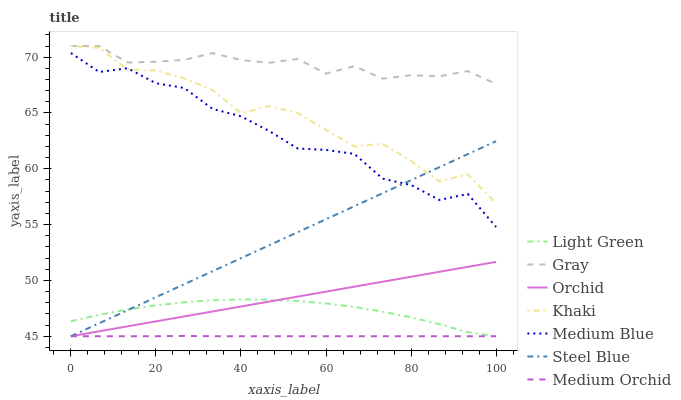Does Khaki have the minimum area under the curve?
Answer yes or no. No. Does Khaki have the maximum area under the curve?
Answer yes or no. No. Is Medium Orchid the smoothest?
Answer yes or no. No. Is Medium Orchid the roughest?
Answer yes or no. No. Does Khaki have the lowest value?
Answer yes or no. No. Does Medium Orchid have the highest value?
Answer yes or no. No. Is Light Green less than Khaki?
Answer yes or no. Yes. Is Gray greater than Light Green?
Answer yes or no. Yes. Does Light Green intersect Khaki?
Answer yes or no. No. 